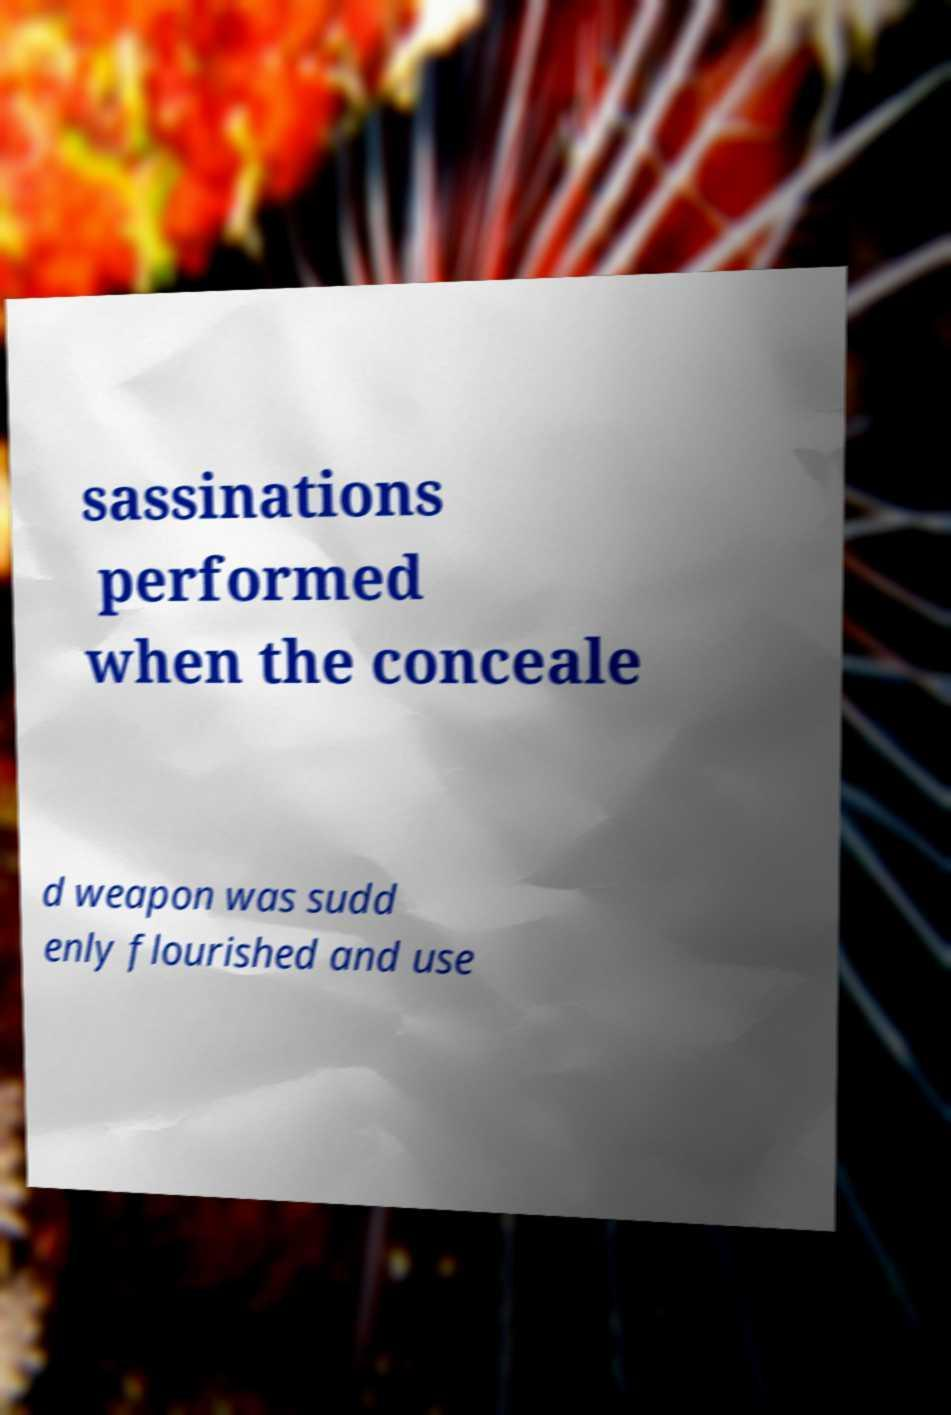Could you extract and type out the text from this image? sassinations performed when the conceale d weapon was sudd enly flourished and use 